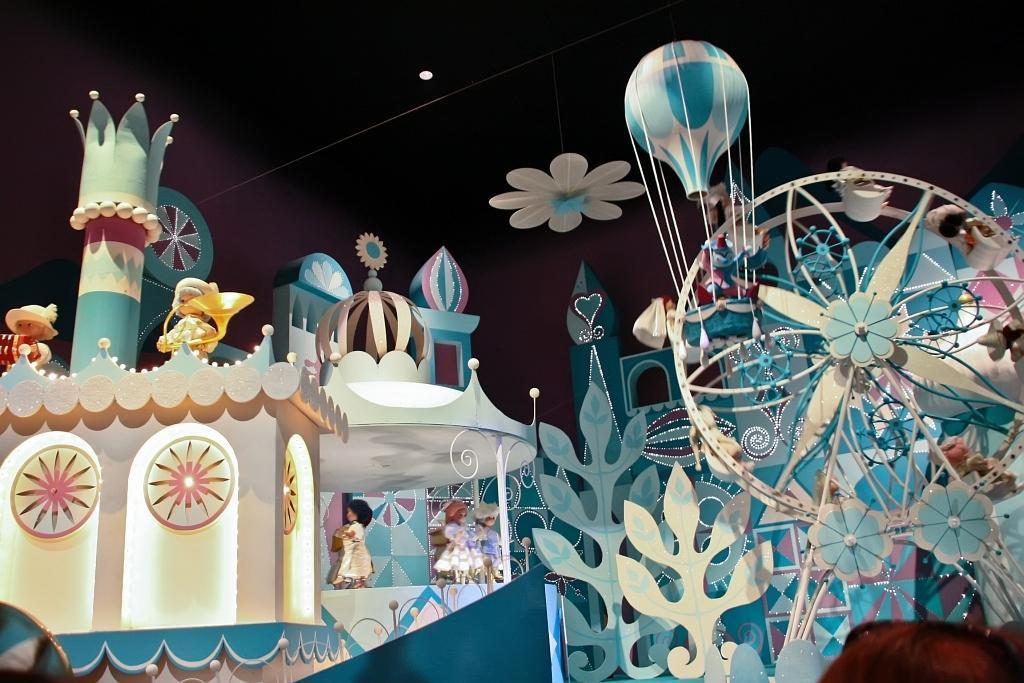Describe this image in one or two sentences. In this image we can see toys and depictions of rides, parachute and other objects. 